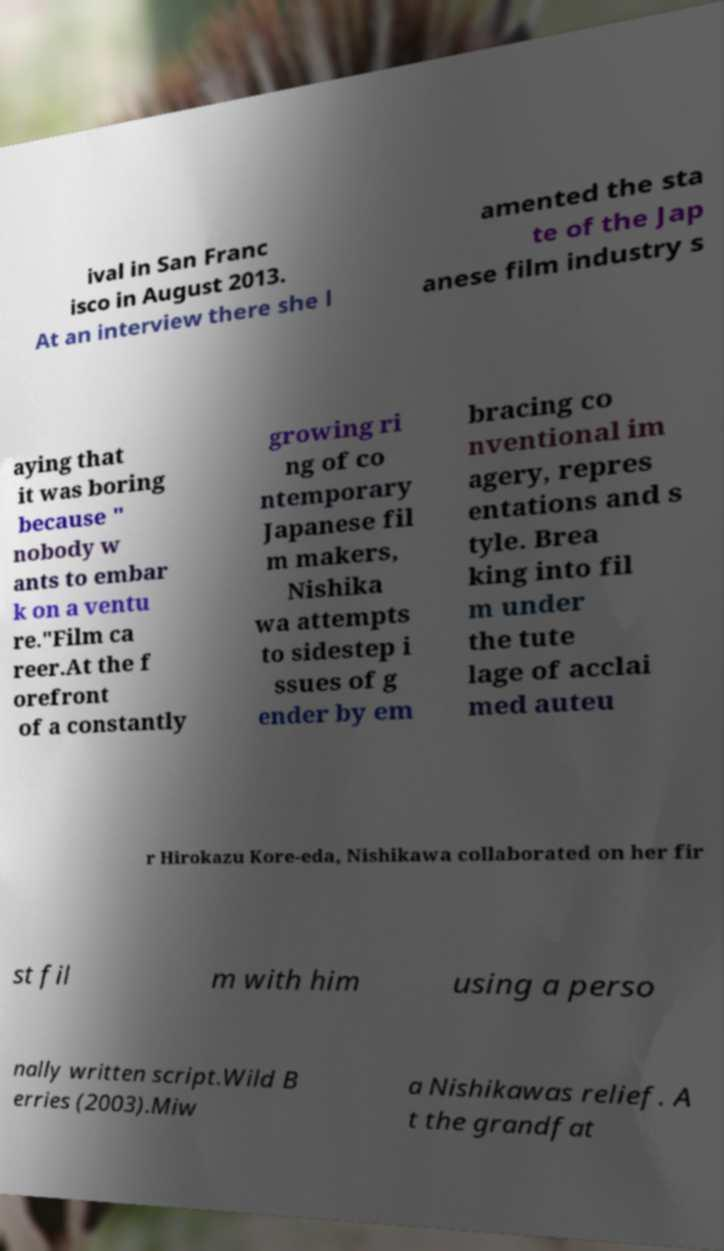There's text embedded in this image that I need extracted. Can you transcribe it verbatim? ival in San Franc isco in August 2013. At an interview there she l amented the sta te of the Jap anese film industry s aying that it was boring because " nobody w ants to embar k on a ventu re."Film ca reer.At the f orefront of a constantly growing ri ng of co ntemporary Japanese fil m makers, Nishika wa attempts to sidestep i ssues of g ender by em bracing co nventional im agery, repres entations and s tyle. Brea king into fil m under the tute lage of acclai med auteu r Hirokazu Kore-eda, Nishikawa collaborated on her fir st fil m with him using a perso nally written script.Wild B erries (2003).Miw a Nishikawas relief. A t the grandfat 